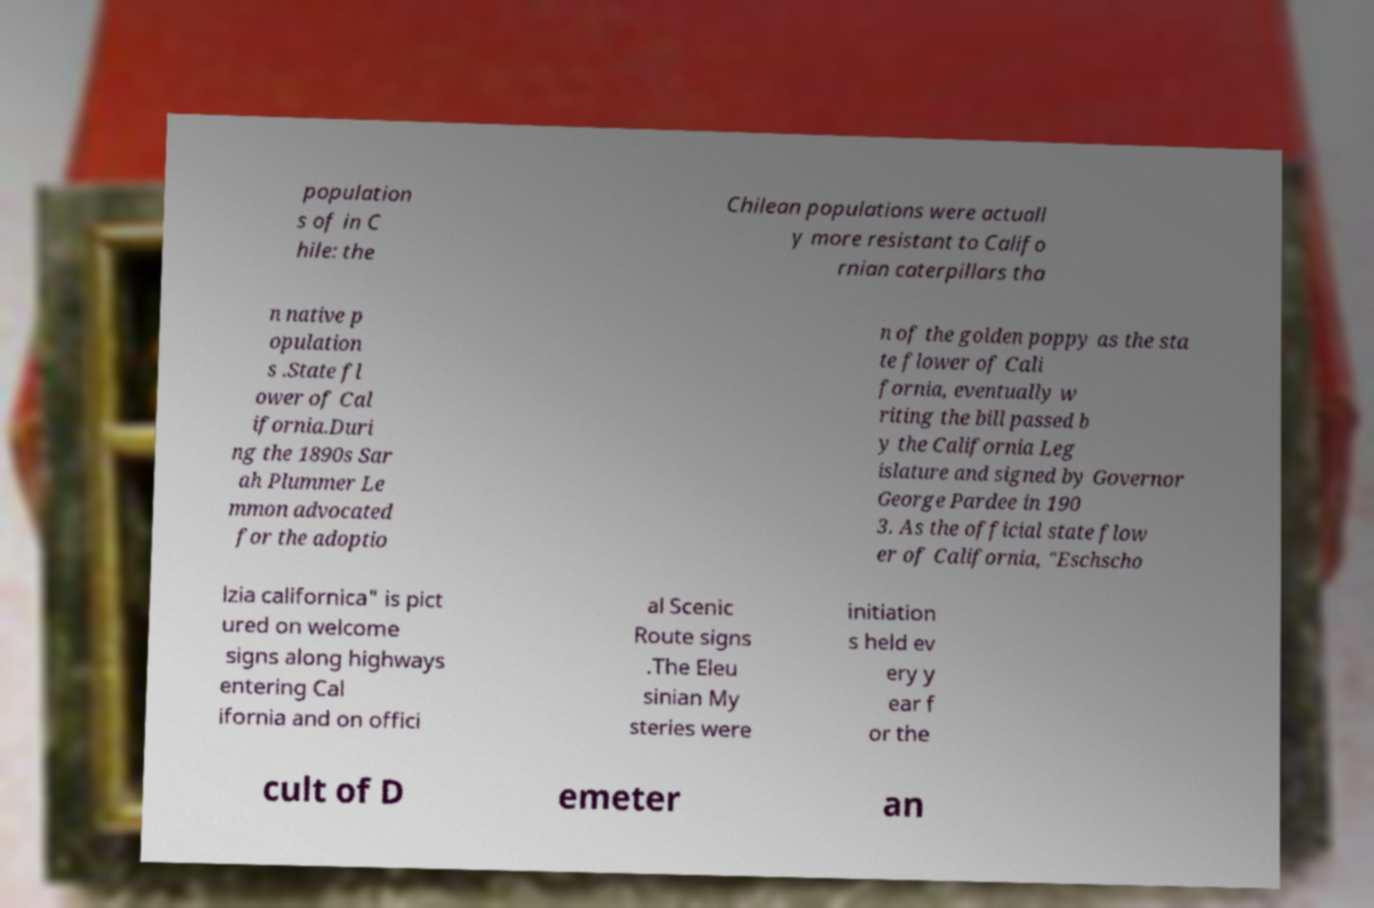Please identify and transcribe the text found in this image. population s of in C hile: the Chilean populations were actuall y more resistant to Califo rnian caterpillars tha n native p opulation s .State fl ower of Cal ifornia.Duri ng the 1890s Sar ah Plummer Le mmon advocated for the adoptio n of the golden poppy as the sta te flower of Cali fornia, eventually w riting the bill passed b y the California Leg islature and signed by Governor George Pardee in 190 3. As the official state flow er of California, "Eschscho lzia californica" is pict ured on welcome signs along highways entering Cal ifornia and on offici al Scenic Route signs .The Eleu sinian My steries were initiation s held ev ery y ear f or the cult of D emeter an 